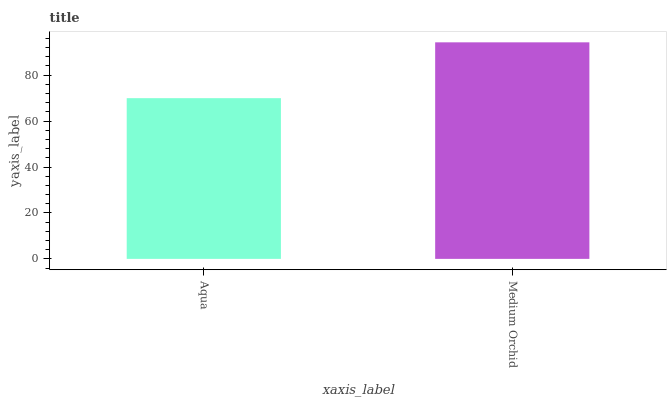Is Aqua the minimum?
Answer yes or no. Yes. Is Medium Orchid the maximum?
Answer yes or no. Yes. Is Medium Orchid the minimum?
Answer yes or no. No. Is Medium Orchid greater than Aqua?
Answer yes or no. Yes. Is Aqua less than Medium Orchid?
Answer yes or no. Yes. Is Aqua greater than Medium Orchid?
Answer yes or no. No. Is Medium Orchid less than Aqua?
Answer yes or no. No. Is Medium Orchid the high median?
Answer yes or no. Yes. Is Aqua the low median?
Answer yes or no. Yes. Is Aqua the high median?
Answer yes or no. No. Is Medium Orchid the low median?
Answer yes or no. No. 